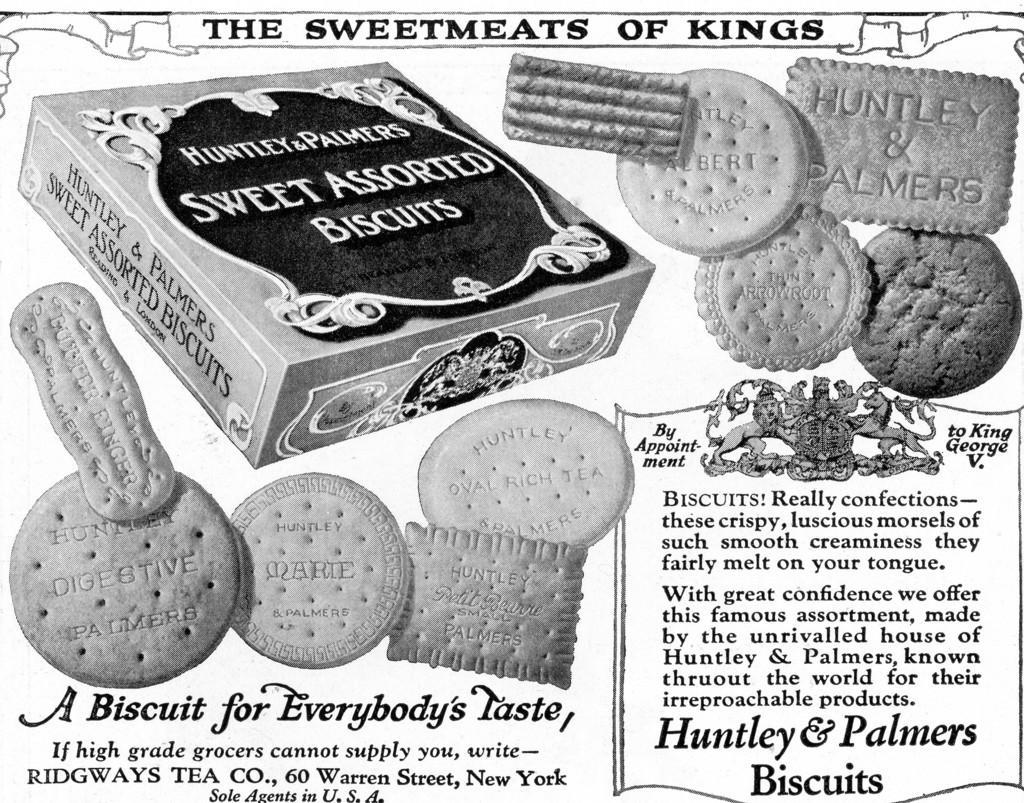Describe this image in one or two sentences. We can see poster,on this poster we can see biscuits,box and text. 